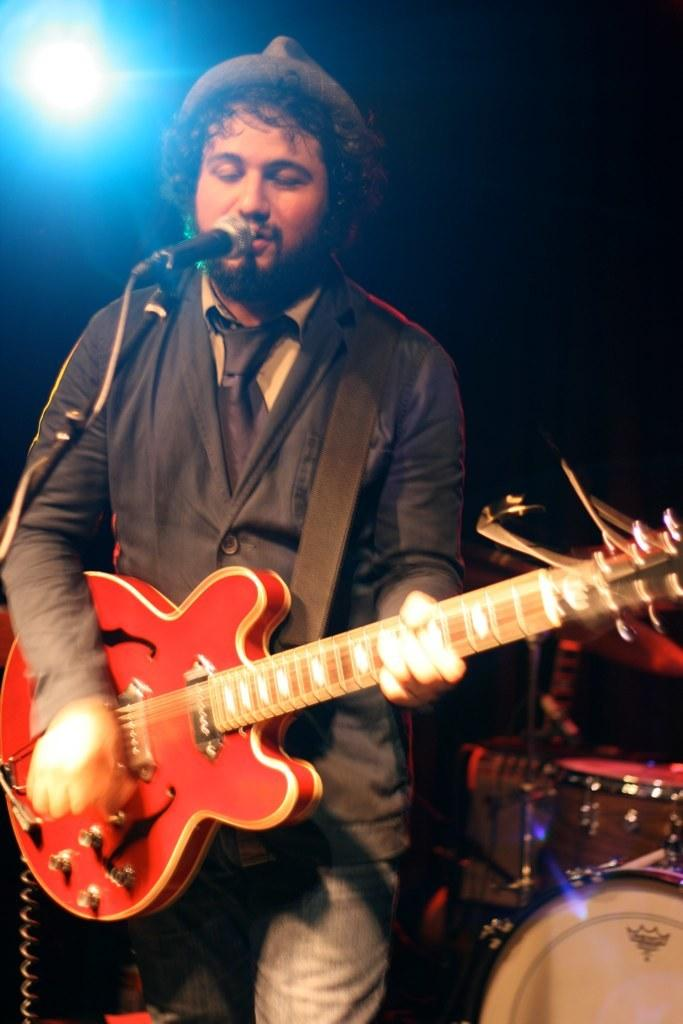What is the man in the image doing? The man is playing a guitar. Where is the man positioned in relation to the microphone? The man is in front of a microphone. What other musical elements can be seen in the image? There are musical instruments in the background of the image. What can be seen in the background of the image besides the musical instruments? There is a light in the background of the image. What type of jail can be seen in the background of the image? There is no jail present in the image; it features a man playing a guitar in front of a microphone, with musical instruments and a light in the background. 